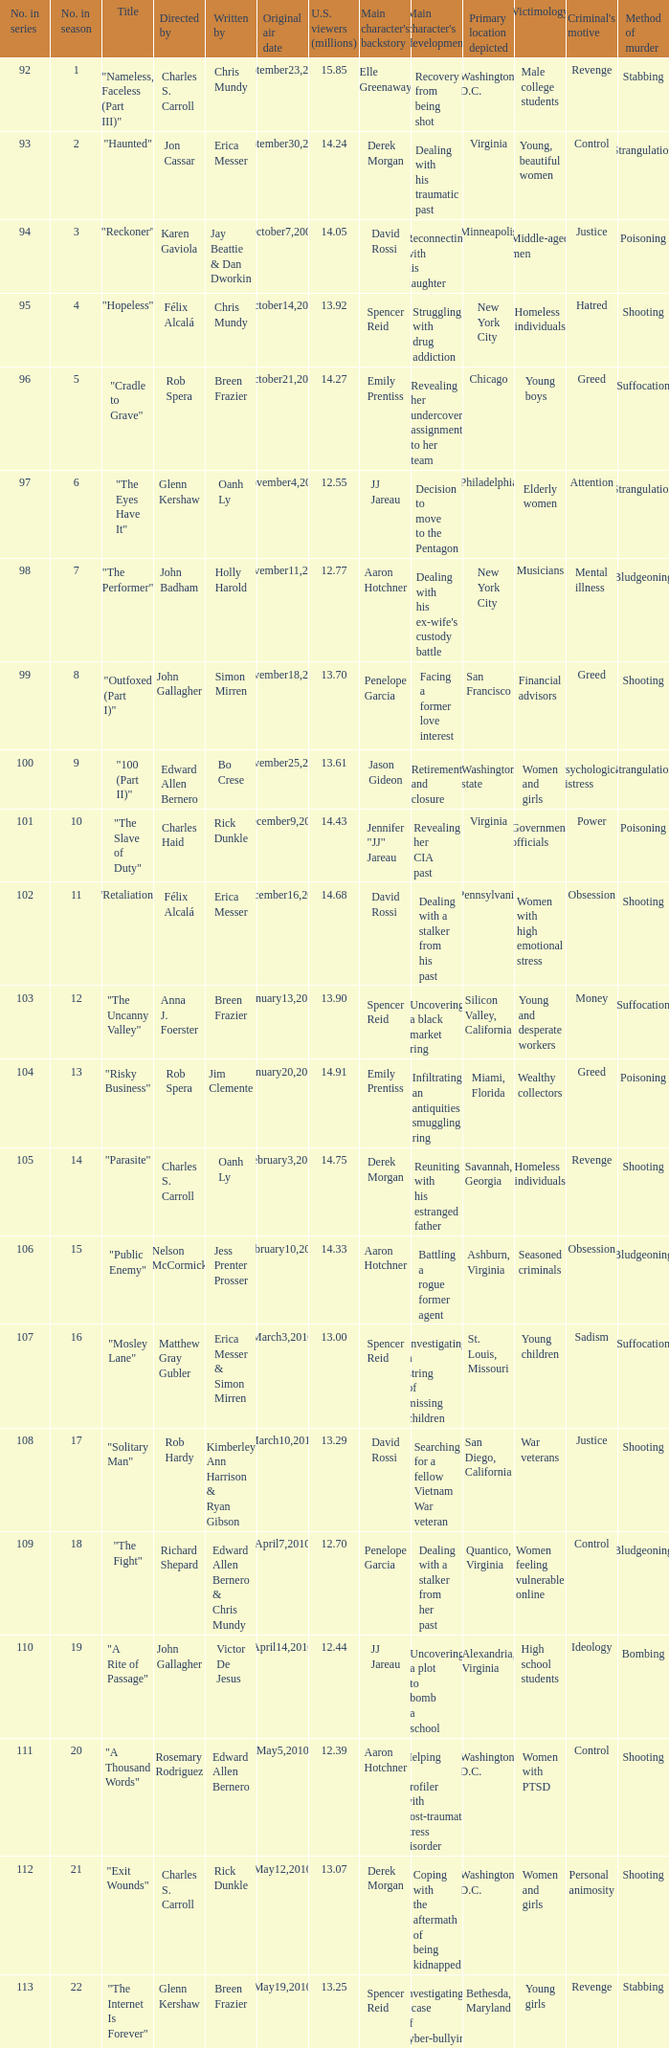On which date was the episode, with 13.92 million us viewers, initially broadcasted? October14,2009. 